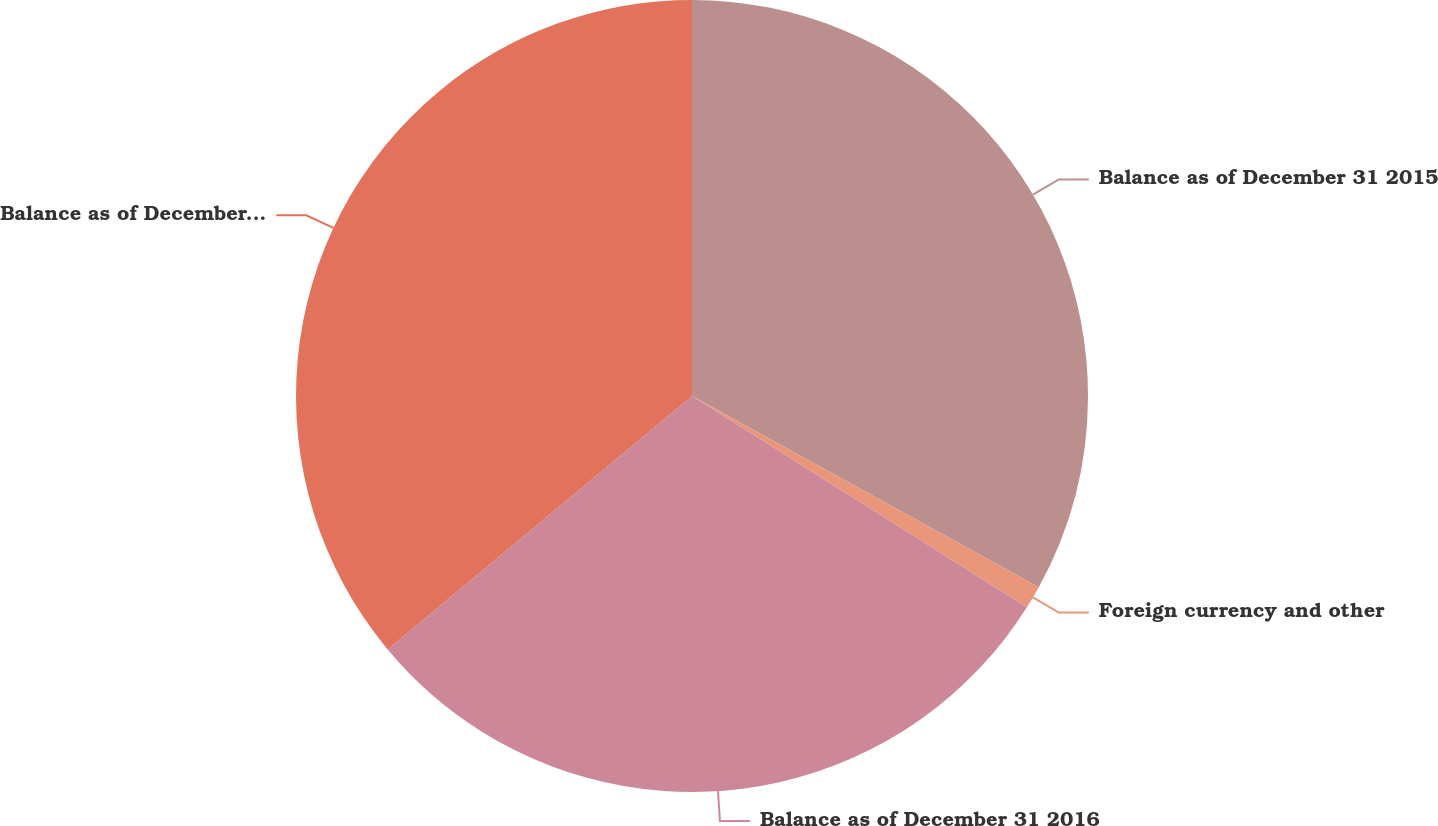Convert chart. <chart><loc_0><loc_0><loc_500><loc_500><pie_chart><fcel>Balance as of December 31 2015<fcel>Foreign currency and other<fcel>Balance as of December 31 2016<fcel>Balance as of December 31 2017<nl><fcel>33.02%<fcel>0.94%<fcel>29.99%<fcel>36.05%<nl></chart> 